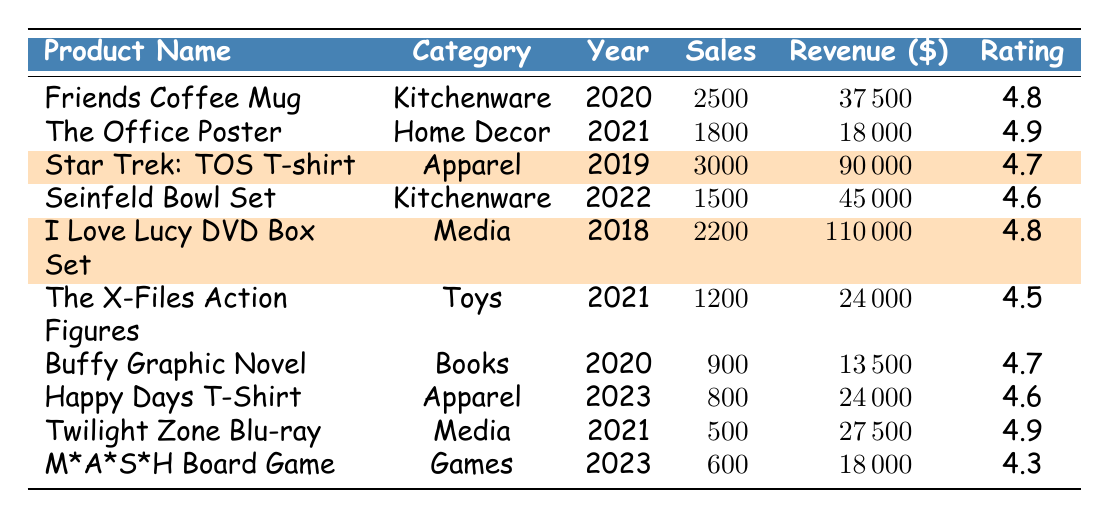What is the total revenue from the "Friends Coffee Mug"? The revenue from the "Friends Coffee Mug" is listed as $37,500 in the table.
Answer: $37,500 How many units of "Star Trek: The Original Series T-shirt" were sold? The sales units for the "Star Trek: The Original Series T-shirt" are listed as 3000.
Answer: 3000 Which product has the highest average rating? The product with the highest average rating is "The Office Poster" with a rating of 4.9.
Answer: The Office Poster What is the total number of sales units for products introduced in 2023? The sales units for products introduced in 2023 are for "Happy Days Vintage-style T-Shirt" (800) and "M*A*S*H Themed Board Game" (600). So, 800 + 600 = 1400 sales units.
Answer: 1400 Is the revenue for the "I Love Lucy DVD Box Set" greater than $100,000? The revenue for the "I Love Lucy DVD Box Set" is $110,000, which is greater than $100,000.
Answer: Yes What is the average revenue of all kitchenware products? There are two kitchenware products listed: "Friends Coffee Mug" ($37,500) and "Seinfeld: 'No Soup for You' Bowl Set" ($45,000). The average revenue is (37500 + 45000) / 2 = $41,250.
Answer: $41,250 How does the sales of "The X-Files Action Figures" compare to "Happy Days Vintage-style T-Shirt"? "The X-Files Action Figures" had 1200 units sold, while "Happy Days Vintage-style T-Shirt" had 800 units. 1200 is greater than 800.
Answer: "The X-Files Action Figures" had higher sales What is the difference in revenue between the highest and lowest-selling product? The highest revenue is $110,000 (I Love Lucy DVD Box Set) and the lowest is $13,500 (Buffy the Vampire Slayer Graphic Novel). The difference is 110000 - 13500 = $96,500.
Answer: $96,500 Which product comes from the 2022 category and what is its revenue? The product from the 2022 category is "Seinfeld: 'No Soup for You' Bowl Set" with a revenue of $45,000.
Answer: Seinfeld: 'No Soup for You' Bowl Set, $45,000 How many products have an average rating of 4.8 or higher? The products with a rating of 4.8 or higher are "Friends Coffee Mug" (4.8), "The Office Poster" (4.9), "I Love Lucy DVD Box Set" (4.8), and "Twilight Zone Collector's Edition Blu-ray" (4.9), totaling 4 products.
Answer: 4 